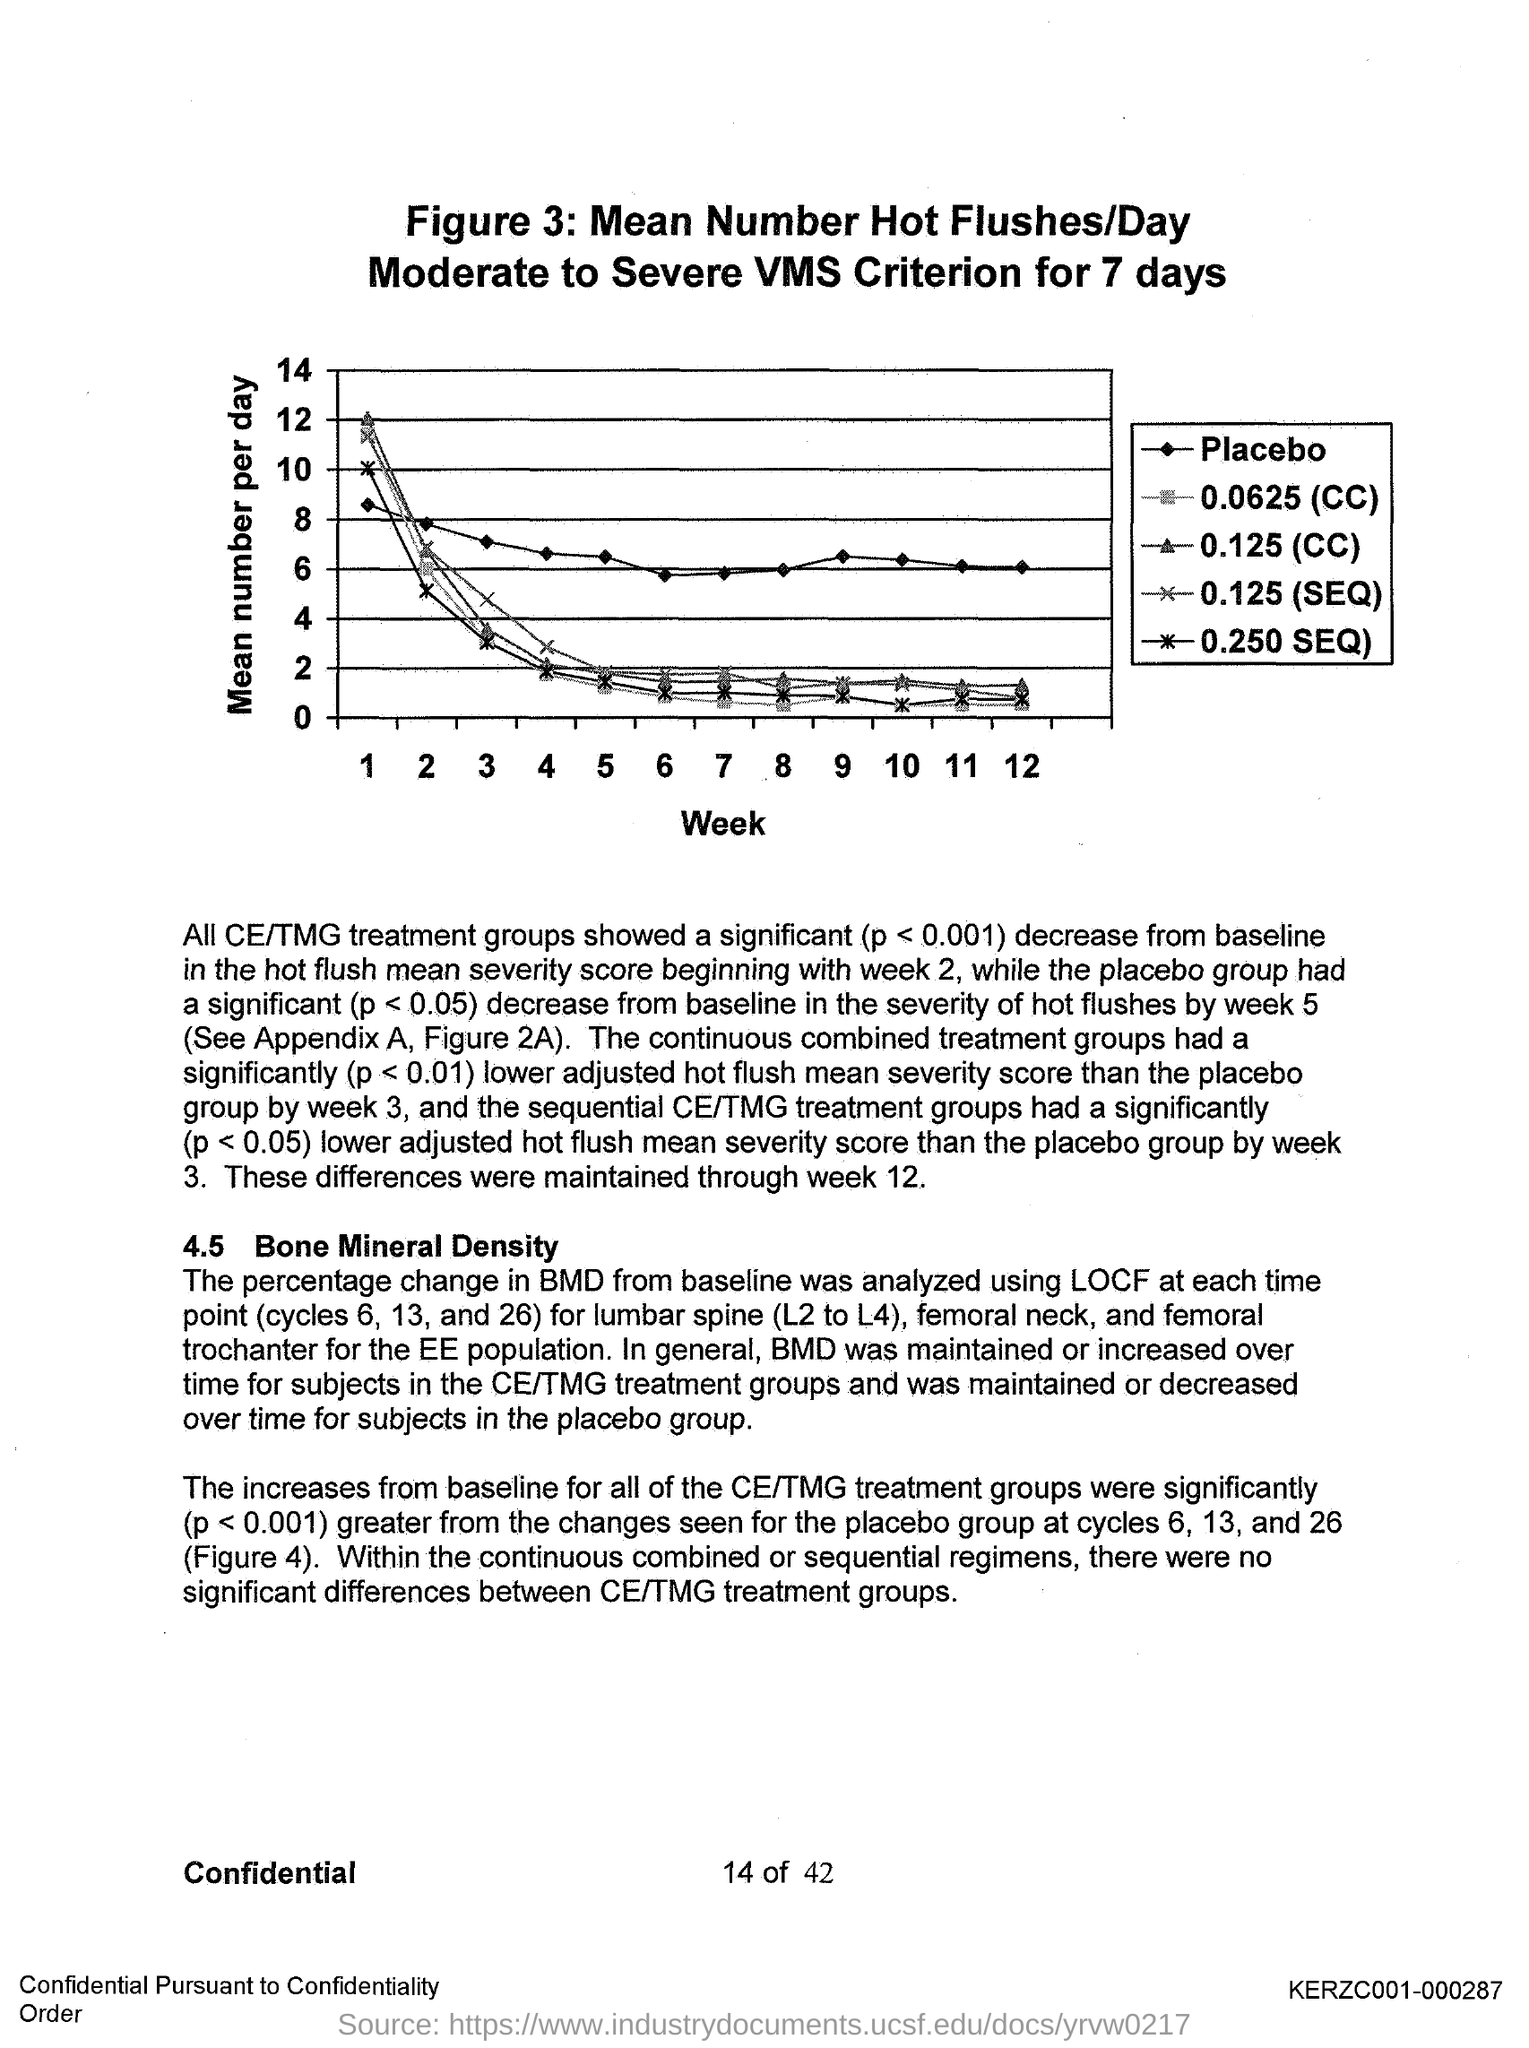Identify some key points in this picture. The x-axis contains the plotted information for the week, which is being questioned. The y-axis in the graph shows the mean number of steps per day for each participant. 